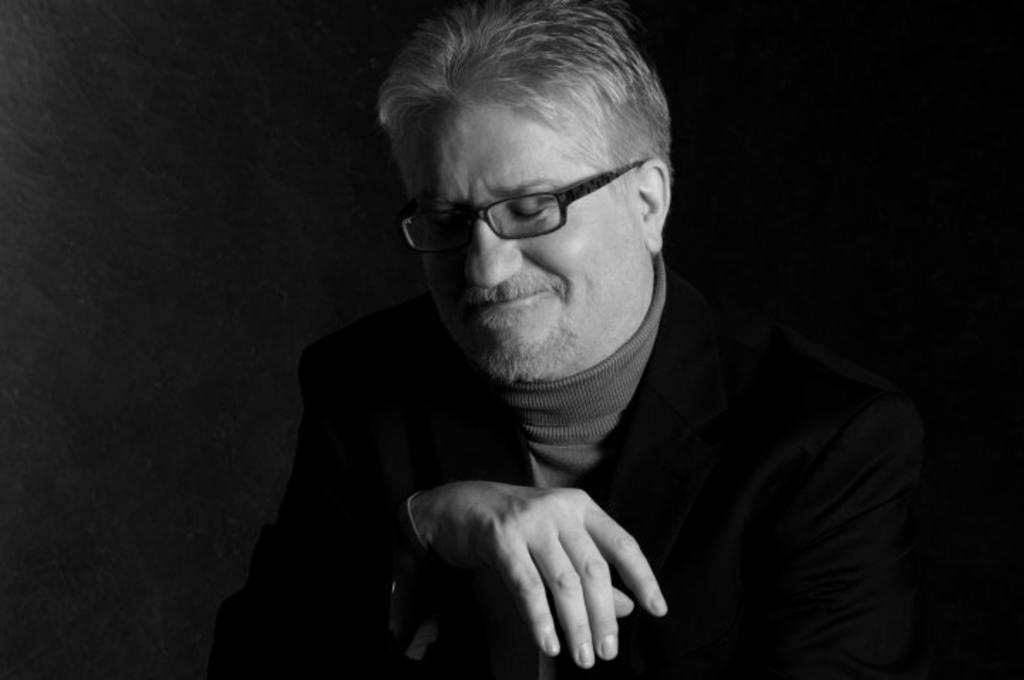Who is the person in the image? There is a man in the image. What is the man wearing in the image? The man is wearing a black coat and glasses (specs). What can be observed about the background of the image? The background of the image is dark. What type of balance does the man have to maintain on the stage in the image? There is no stage present in the image, and the man is not performing any balancing act. 